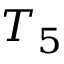<formula> <loc_0><loc_0><loc_500><loc_500>T _ { 5 }</formula> 